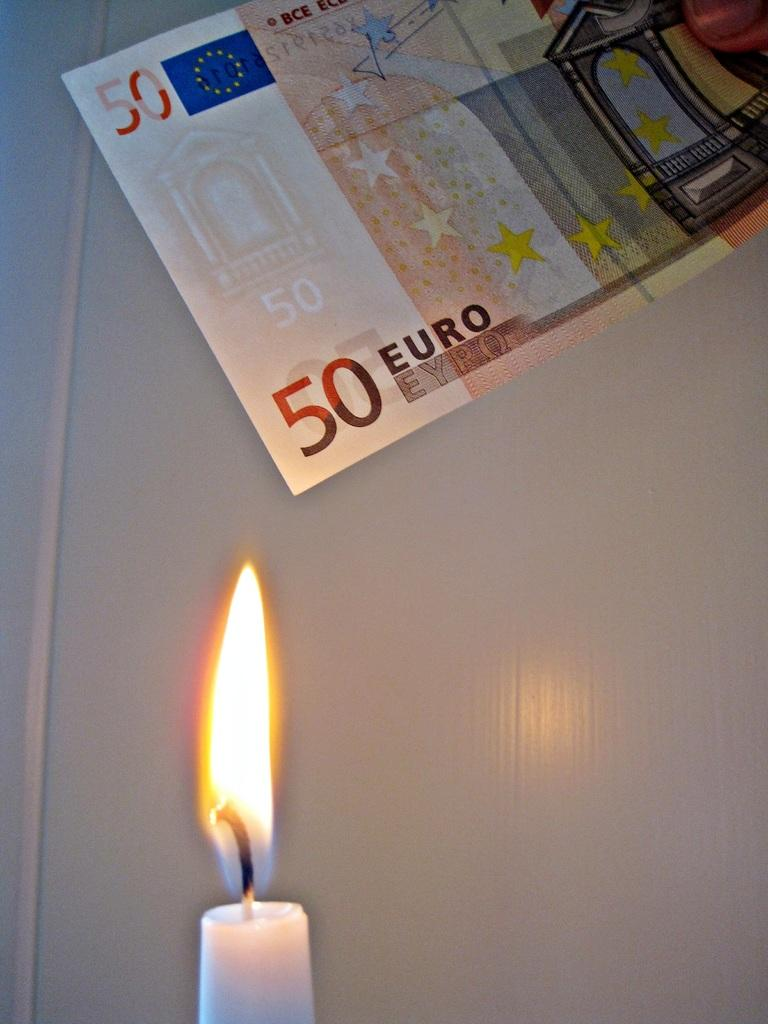What is the person holding in the image? The person is holding the euro in the image. What can be seen in the background of the image? There is a wall in the background of the image. What design element is present on the euro? The euro has stars on it. What is located at the bottom of the image? There is a candle at the bottom of the image. What type of ear is visible on the person holding the euro in the image? There is no ear visible on the person holding the euro in the image. What country is depicted in the picture of the building? The facts provided do not mention a specific country or building, so it cannot be determined from the image. 